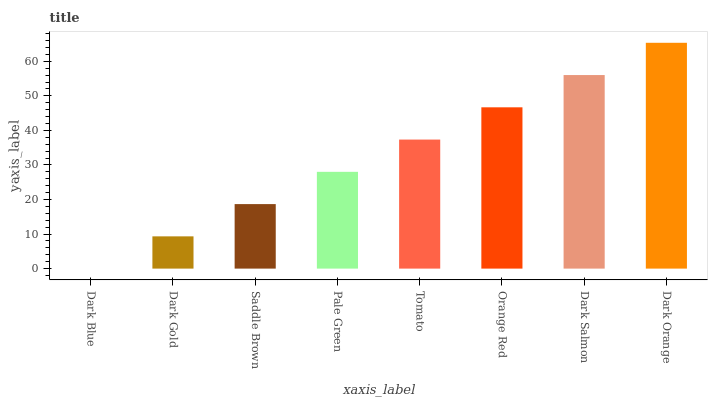Is Dark Blue the minimum?
Answer yes or no. Yes. Is Dark Orange the maximum?
Answer yes or no. Yes. Is Dark Gold the minimum?
Answer yes or no. No. Is Dark Gold the maximum?
Answer yes or no. No. Is Dark Gold greater than Dark Blue?
Answer yes or no. Yes. Is Dark Blue less than Dark Gold?
Answer yes or no. Yes. Is Dark Blue greater than Dark Gold?
Answer yes or no. No. Is Dark Gold less than Dark Blue?
Answer yes or no. No. Is Tomato the high median?
Answer yes or no. Yes. Is Pale Green the low median?
Answer yes or no. Yes. Is Dark Orange the high median?
Answer yes or no. No. Is Dark Blue the low median?
Answer yes or no. No. 